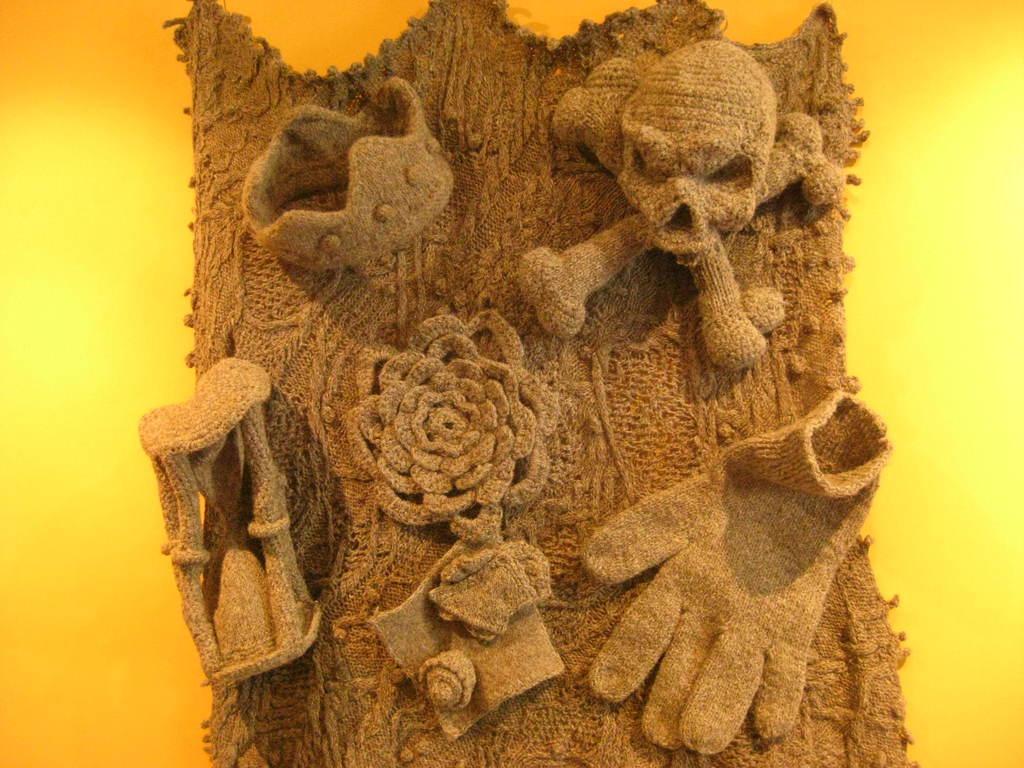Can you describe this image briefly? In the foreground I can see a wool cloth on which I can see a skeleton, glove, flower, ear ring and so on. In the background I can see orange and yellow color. This image is taken may be in a house. 